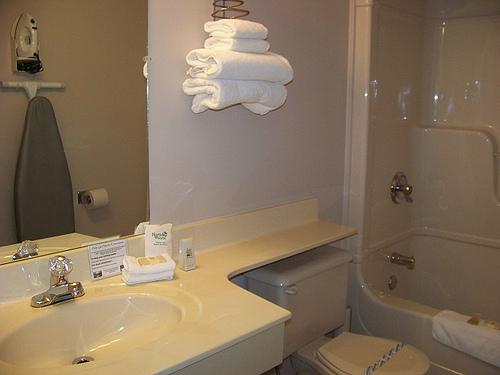How many towels are on the rack?
Be succinct. 4. Is this room in a home?
Concise answer only. No. How many rolls of toilet paper do you see?
Write a very short answer. 0. 